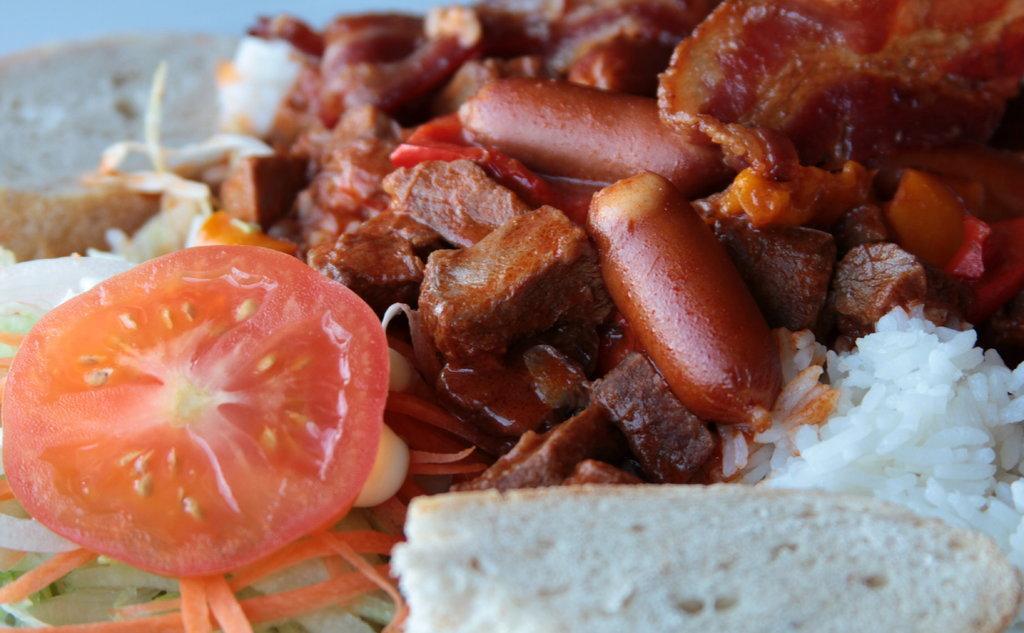Could you give a brief overview of what you see in this image? In this image I can see food items like tomato, bread, rice, carrot and some other. 